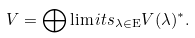Convert formula to latex. <formula><loc_0><loc_0><loc_500><loc_500>V = \bigoplus \lim i t s _ { \lambda \in \mathrm E } V ( \lambda ) ^ { * } .</formula> 